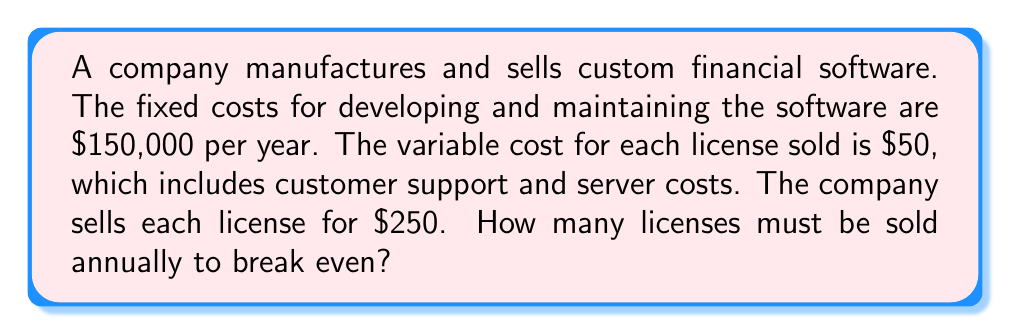Solve this math problem. To solve this problem, we need to use the break-even formula:

1) Let $x$ be the number of licenses sold.

2) Revenue function: $R(x) = 250x$

3) Cost function: $C(x) = 150000 + 50x$

4) At the break-even point, revenue equals cost:
   $R(x) = C(x)$

5) Substitute the functions:
   $250x = 150000 + 50x$

6) Solve for $x$:
   $250x - 50x = 150000$
   $200x = 150000$

7) Divide both sides by 200:
   $x = \frac{150000}{200} = 750$

Therefore, the company needs to sell 750 licenses to break even.

To verify:
Revenue: $R(750) = 250 \cdot 750 = 187500$
Cost: $C(750) = 150000 + 50 \cdot 750 = 187500$

Indeed, $R(750) = C(750)$, confirming the break-even point.
Answer: 750 licenses 